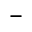Convert formula to latex. <formula><loc_0><loc_0><loc_500><loc_500>-</formula> 